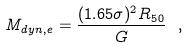<formula> <loc_0><loc_0><loc_500><loc_500>M _ { d y n , e } = \frac { ( 1 . 6 5 \sigma ) ^ { 2 } R _ { 5 0 } } { G } \ ,</formula> 